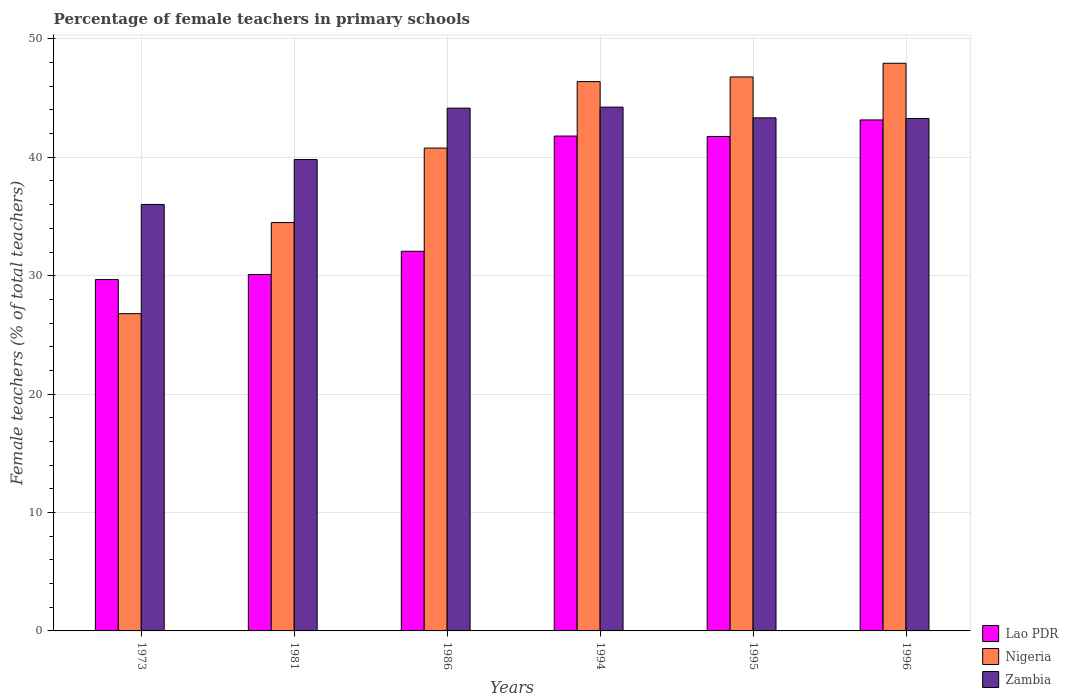How many different coloured bars are there?
Offer a terse response. 3. Are the number of bars on each tick of the X-axis equal?
Make the answer very short. Yes. How many bars are there on the 4th tick from the left?
Your response must be concise. 3. What is the label of the 4th group of bars from the left?
Your response must be concise. 1994. In how many cases, is the number of bars for a given year not equal to the number of legend labels?
Offer a very short reply. 0. What is the percentage of female teachers in Nigeria in 1994?
Your answer should be compact. 46.39. Across all years, what is the maximum percentage of female teachers in Zambia?
Keep it short and to the point. 44.24. Across all years, what is the minimum percentage of female teachers in Nigeria?
Your response must be concise. 26.8. In which year was the percentage of female teachers in Zambia maximum?
Make the answer very short. 1994. In which year was the percentage of female teachers in Lao PDR minimum?
Provide a short and direct response. 1973. What is the total percentage of female teachers in Zambia in the graph?
Make the answer very short. 250.83. What is the difference between the percentage of female teachers in Zambia in 1973 and that in 1995?
Provide a succinct answer. -7.32. What is the difference between the percentage of female teachers in Nigeria in 1996 and the percentage of female teachers in Lao PDR in 1995?
Offer a very short reply. 6.19. What is the average percentage of female teachers in Zambia per year?
Make the answer very short. 41.8. In the year 1995, what is the difference between the percentage of female teachers in Lao PDR and percentage of female teachers in Zambia?
Your answer should be very brief. -1.58. In how many years, is the percentage of female teachers in Lao PDR greater than 14 %?
Give a very brief answer. 6. What is the ratio of the percentage of female teachers in Lao PDR in 1973 to that in 1986?
Make the answer very short. 0.93. Is the difference between the percentage of female teachers in Lao PDR in 1981 and 1995 greater than the difference between the percentage of female teachers in Zambia in 1981 and 1995?
Your answer should be very brief. No. What is the difference between the highest and the second highest percentage of female teachers in Lao PDR?
Offer a terse response. 1.36. What is the difference between the highest and the lowest percentage of female teachers in Lao PDR?
Give a very brief answer. 13.48. Is the sum of the percentage of female teachers in Zambia in 1981 and 1986 greater than the maximum percentage of female teachers in Lao PDR across all years?
Keep it short and to the point. Yes. What does the 3rd bar from the left in 1981 represents?
Your answer should be compact. Zambia. What does the 2nd bar from the right in 1996 represents?
Your answer should be very brief. Nigeria. How many bars are there?
Provide a succinct answer. 18. Does the graph contain any zero values?
Ensure brevity in your answer.  No. Does the graph contain grids?
Your response must be concise. Yes. How many legend labels are there?
Provide a succinct answer. 3. What is the title of the graph?
Make the answer very short. Percentage of female teachers in primary schools. Does "Armenia" appear as one of the legend labels in the graph?
Your response must be concise. No. What is the label or title of the X-axis?
Ensure brevity in your answer.  Years. What is the label or title of the Y-axis?
Keep it short and to the point. Female teachers (% of total teachers). What is the Female teachers (% of total teachers) of Lao PDR in 1973?
Your answer should be compact. 29.67. What is the Female teachers (% of total teachers) in Nigeria in 1973?
Offer a terse response. 26.8. What is the Female teachers (% of total teachers) in Zambia in 1973?
Your answer should be compact. 36.02. What is the Female teachers (% of total teachers) in Lao PDR in 1981?
Your answer should be compact. 30.1. What is the Female teachers (% of total teachers) of Nigeria in 1981?
Your answer should be very brief. 34.49. What is the Female teachers (% of total teachers) in Zambia in 1981?
Your answer should be compact. 39.81. What is the Female teachers (% of total teachers) of Lao PDR in 1986?
Your answer should be very brief. 32.06. What is the Female teachers (% of total teachers) in Nigeria in 1986?
Your answer should be very brief. 40.78. What is the Female teachers (% of total teachers) of Zambia in 1986?
Give a very brief answer. 44.15. What is the Female teachers (% of total teachers) of Lao PDR in 1994?
Offer a terse response. 41.79. What is the Female teachers (% of total teachers) of Nigeria in 1994?
Your answer should be compact. 46.39. What is the Female teachers (% of total teachers) in Zambia in 1994?
Ensure brevity in your answer.  44.24. What is the Female teachers (% of total teachers) of Lao PDR in 1995?
Provide a succinct answer. 41.76. What is the Female teachers (% of total teachers) in Nigeria in 1995?
Ensure brevity in your answer.  46.79. What is the Female teachers (% of total teachers) in Zambia in 1995?
Provide a short and direct response. 43.33. What is the Female teachers (% of total teachers) of Lao PDR in 1996?
Provide a short and direct response. 43.16. What is the Female teachers (% of total teachers) in Nigeria in 1996?
Your answer should be very brief. 47.94. What is the Female teachers (% of total teachers) of Zambia in 1996?
Your answer should be compact. 43.28. Across all years, what is the maximum Female teachers (% of total teachers) in Lao PDR?
Keep it short and to the point. 43.16. Across all years, what is the maximum Female teachers (% of total teachers) in Nigeria?
Keep it short and to the point. 47.94. Across all years, what is the maximum Female teachers (% of total teachers) in Zambia?
Provide a short and direct response. 44.24. Across all years, what is the minimum Female teachers (% of total teachers) in Lao PDR?
Ensure brevity in your answer.  29.67. Across all years, what is the minimum Female teachers (% of total teachers) of Nigeria?
Give a very brief answer. 26.8. Across all years, what is the minimum Female teachers (% of total teachers) in Zambia?
Give a very brief answer. 36.02. What is the total Female teachers (% of total teachers) of Lao PDR in the graph?
Provide a short and direct response. 218.55. What is the total Female teachers (% of total teachers) of Nigeria in the graph?
Give a very brief answer. 243.19. What is the total Female teachers (% of total teachers) of Zambia in the graph?
Provide a short and direct response. 250.83. What is the difference between the Female teachers (% of total teachers) of Lao PDR in 1973 and that in 1981?
Make the answer very short. -0.43. What is the difference between the Female teachers (% of total teachers) of Nigeria in 1973 and that in 1981?
Make the answer very short. -7.69. What is the difference between the Female teachers (% of total teachers) of Zambia in 1973 and that in 1981?
Offer a terse response. -3.79. What is the difference between the Female teachers (% of total teachers) in Lao PDR in 1973 and that in 1986?
Provide a short and direct response. -2.39. What is the difference between the Female teachers (% of total teachers) of Nigeria in 1973 and that in 1986?
Offer a terse response. -13.98. What is the difference between the Female teachers (% of total teachers) of Zambia in 1973 and that in 1986?
Ensure brevity in your answer.  -8.14. What is the difference between the Female teachers (% of total teachers) of Lao PDR in 1973 and that in 1994?
Give a very brief answer. -12.12. What is the difference between the Female teachers (% of total teachers) in Nigeria in 1973 and that in 1994?
Ensure brevity in your answer.  -19.6. What is the difference between the Female teachers (% of total teachers) of Zambia in 1973 and that in 1994?
Your answer should be very brief. -8.22. What is the difference between the Female teachers (% of total teachers) in Lao PDR in 1973 and that in 1995?
Ensure brevity in your answer.  -12.08. What is the difference between the Female teachers (% of total teachers) of Nigeria in 1973 and that in 1995?
Your response must be concise. -19.99. What is the difference between the Female teachers (% of total teachers) in Zambia in 1973 and that in 1995?
Offer a terse response. -7.32. What is the difference between the Female teachers (% of total teachers) in Lao PDR in 1973 and that in 1996?
Keep it short and to the point. -13.48. What is the difference between the Female teachers (% of total teachers) in Nigeria in 1973 and that in 1996?
Provide a succinct answer. -21.15. What is the difference between the Female teachers (% of total teachers) in Zambia in 1973 and that in 1996?
Your answer should be very brief. -7.26. What is the difference between the Female teachers (% of total teachers) in Lao PDR in 1981 and that in 1986?
Provide a succinct answer. -1.96. What is the difference between the Female teachers (% of total teachers) in Nigeria in 1981 and that in 1986?
Offer a very short reply. -6.29. What is the difference between the Female teachers (% of total teachers) in Zambia in 1981 and that in 1986?
Make the answer very short. -4.34. What is the difference between the Female teachers (% of total teachers) in Lao PDR in 1981 and that in 1994?
Ensure brevity in your answer.  -11.69. What is the difference between the Female teachers (% of total teachers) of Nigeria in 1981 and that in 1994?
Give a very brief answer. -11.9. What is the difference between the Female teachers (% of total teachers) in Zambia in 1981 and that in 1994?
Offer a terse response. -4.43. What is the difference between the Female teachers (% of total teachers) in Lao PDR in 1981 and that in 1995?
Your answer should be very brief. -11.66. What is the difference between the Female teachers (% of total teachers) of Nigeria in 1981 and that in 1995?
Keep it short and to the point. -12.3. What is the difference between the Female teachers (% of total teachers) in Zambia in 1981 and that in 1995?
Your answer should be compact. -3.52. What is the difference between the Female teachers (% of total teachers) in Lao PDR in 1981 and that in 1996?
Offer a terse response. -13.06. What is the difference between the Female teachers (% of total teachers) in Nigeria in 1981 and that in 1996?
Ensure brevity in your answer.  -13.45. What is the difference between the Female teachers (% of total teachers) of Zambia in 1981 and that in 1996?
Keep it short and to the point. -3.47. What is the difference between the Female teachers (% of total teachers) in Lao PDR in 1986 and that in 1994?
Your response must be concise. -9.73. What is the difference between the Female teachers (% of total teachers) in Nigeria in 1986 and that in 1994?
Your answer should be very brief. -5.61. What is the difference between the Female teachers (% of total teachers) of Zambia in 1986 and that in 1994?
Make the answer very short. -0.09. What is the difference between the Female teachers (% of total teachers) of Lao PDR in 1986 and that in 1995?
Your response must be concise. -9.69. What is the difference between the Female teachers (% of total teachers) in Nigeria in 1986 and that in 1995?
Keep it short and to the point. -6.01. What is the difference between the Female teachers (% of total teachers) in Zambia in 1986 and that in 1995?
Your response must be concise. 0.82. What is the difference between the Female teachers (% of total teachers) in Lao PDR in 1986 and that in 1996?
Provide a succinct answer. -11.09. What is the difference between the Female teachers (% of total teachers) in Nigeria in 1986 and that in 1996?
Provide a succinct answer. -7.16. What is the difference between the Female teachers (% of total teachers) of Zambia in 1986 and that in 1996?
Provide a short and direct response. 0.87. What is the difference between the Female teachers (% of total teachers) of Lao PDR in 1994 and that in 1995?
Provide a succinct answer. 0.04. What is the difference between the Female teachers (% of total teachers) of Nigeria in 1994 and that in 1995?
Provide a short and direct response. -0.39. What is the difference between the Female teachers (% of total teachers) in Zambia in 1994 and that in 1995?
Ensure brevity in your answer.  0.91. What is the difference between the Female teachers (% of total teachers) in Lao PDR in 1994 and that in 1996?
Your answer should be very brief. -1.36. What is the difference between the Female teachers (% of total teachers) of Nigeria in 1994 and that in 1996?
Make the answer very short. -1.55. What is the difference between the Female teachers (% of total teachers) in Zambia in 1994 and that in 1996?
Offer a very short reply. 0.96. What is the difference between the Female teachers (% of total teachers) in Lao PDR in 1995 and that in 1996?
Offer a terse response. -1.4. What is the difference between the Female teachers (% of total teachers) in Nigeria in 1995 and that in 1996?
Your response must be concise. -1.16. What is the difference between the Female teachers (% of total teachers) in Zambia in 1995 and that in 1996?
Offer a terse response. 0.05. What is the difference between the Female teachers (% of total teachers) in Lao PDR in 1973 and the Female teachers (% of total teachers) in Nigeria in 1981?
Your response must be concise. -4.82. What is the difference between the Female teachers (% of total teachers) of Lao PDR in 1973 and the Female teachers (% of total teachers) of Zambia in 1981?
Provide a succinct answer. -10.14. What is the difference between the Female teachers (% of total teachers) of Nigeria in 1973 and the Female teachers (% of total teachers) of Zambia in 1981?
Make the answer very short. -13.01. What is the difference between the Female teachers (% of total teachers) of Lao PDR in 1973 and the Female teachers (% of total teachers) of Nigeria in 1986?
Your answer should be very brief. -11.11. What is the difference between the Female teachers (% of total teachers) of Lao PDR in 1973 and the Female teachers (% of total teachers) of Zambia in 1986?
Your response must be concise. -14.48. What is the difference between the Female teachers (% of total teachers) in Nigeria in 1973 and the Female teachers (% of total teachers) in Zambia in 1986?
Your answer should be very brief. -17.35. What is the difference between the Female teachers (% of total teachers) in Lao PDR in 1973 and the Female teachers (% of total teachers) in Nigeria in 1994?
Offer a very short reply. -16.72. What is the difference between the Female teachers (% of total teachers) of Lao PDR in 1973 and the Female teachers (% of total teachers) of Zambia in 1994?
Keep it short and to the point. -14.56. What is the difference between the Female teachers (% of total teachers) in Nigeria in 1973 and the Female teachers (% of total teachers) in Zambia in 1994?
Make the answer very short. -17.44. What is the difference between the Female teachers (% of total teachers) of Lao PDR in 1973 and the Female teachers (% of total teachers) of Nigeria in 1995?
Make the answer very short. -17.11. What is the difference between the Female teachers (% of total teachers) in Lao PDR in 1973 and the Female teachers (% of total teachers) in Zambia in 1995?
Give a very brief answer. -13.66. What is the difference between the Female teachers (% of total teachers) in Nigeria in 1973 and the Female teachers (% of total teachers) in Zambia in 1995?
Provide a short and direct response. -16.54. What is the difference between the Female teachers (% of total teachers) of Lao PDR in 1973 and the Female teachers (% of total teachers) of Nigeria in 1996?
Your answer should be compact. -18.27. What is the difference between the Female teachers (% of total teachers) of Lao PDR in 1973 and the Female teachers (% of total teachers) of Zambia in 1996?
Provide a short and direct response. -13.6. What is the difference between the Female teachers (% of total teachers) in Nigeria in 1973 and the Female teachers (% of total teachers) in Zambia in 1996?
Offer a terse response. -16.48. What is the difference between the Female teachers (% of total teachers) in Lao PDR in 1981 and the Female teachers (% of total teachers) in Nigeria in 1986?
Offer a terse response. -10.68. What is the difference between the Female teachers (% of total teachers) in Lao PDR in 1981 and the Female teachers (% of total teachers) in Zambia in 1986?
Make the answer very short. -14.05. What is the difference between the Female teachers (% of total teachers) of Nigeria in 1981 and the Female teachers (% of total teachers) of Zambia in 1986?
Ensure brevity in your answer.  -9.66. What is the difference between the Female teachers (% of total teachers) in Lao PDR in 1981 and the Female teachers (% of total teachers) in Nigeria in 1994?
Make the answer very short. -16.29. What is the difference between the Female teachers (% of total teachers) of Lao PDR in 1981 and the Female teachers (% of total teachers) of Zambia in 1994?
Give a very brief answer. -14.14. What is the difference between the Female teachers (% of total teachers) of Nigeria in 1981 and the Female teachers (% of total teachers) of Zambia in 1994?
Provide a succinct answer. -9.75. What is the difference between the Female teachers (% of total teachers) of Lao PDR in 1981 and the Female teachers (% of total teachers) of Nigeria in 1995?
Make the answer very short. -16.68. What is the difference between the Female teachers (% of total teachers) in Lao PDR in 1981 and the Female teachers (% of total teachers) in Zambia in 1995?
Provide a succinct answer. -13.23. What is the difference between the Female teachers (% of total teachers) in Nigeria in 1981 and the Female teachers (% of total teachers) in Zambia in 1995?
Give a very brief answer. -8.84. What is the difference between the Female teachers (% of total teachers) in Lao PDR in 1981 and the Female teachers (% of total teachers) in Nigeria in 1996?
Provide a succinct answer. -17.84. What is the difference between the Female teachers (% of total teachers) in Lao PDR in 1981 and the Female teachers (% of total teachers) in Zambia in 1996?
Your answer should be very brief. -13.18. What is the difference between the Female teachers (% of total teachers) in Nigeria in 1981 and the Female teachers (% of total teachers) in Zambia in 1996?
Provide a succinct answer. -8.79. What is the difference between the Female teachers (% of total teachers) of Lao PDR in 1986 and the Female teachers (% of total teachers) of Nigeria in 1994?
Give a very brief answer. -14.33. What is the difference between the Female teachers (% of total teachers) in Lao PDR in 1986 and the Female teachers (% of total teachers) in Zambia in 1994?
Make the answer very short. -12.17. What is the difference between the Female teachers (% of total teachers) of Nigeria in 1986 and the Female teachers (% of total teachers) of Zambia in 1994?
Provide a succinct answer. -3.46. What is the difference between the Female teachers (% of total teachers) of Lao PDR in 1986 and the Female teachers (% of total teachers) of Nigeria in 1995?
Provide a short and direct response. -14.72. What is the difference between the Female teachers (% of total teachers) of Lao PDR in 1986 and the Female teachers (% of total teachers) of Zambia in 1995?
Ensure brevity in your answer.  -11.27. What is the difference between the Female teachers (% of total teachers) in Nigeria in 1986 and the Female teachers (% of total teachers) in Zambia in 1995?
Offer a very short reply. -2.55. What is the difference between the Female teachers (% of total teachers) in Lao PDR in 1986 and the Female teachers (% of total teachers) in Nigeria in 1996?
Provide a succinct answer. -15.88. What is the difference between the Female teachers (% of total teachers) of Lao PDR in 1986 and the Female teachers (% of total teachers) of Zambia in 1996?
Your answer should be very brief. -11.21. What is the difference between the Female teachers (% of total teachers) in Nigeria in 1986 and the Female teachers (% of total teachers) in Zambia in 1996?
Offer a terse response. -2.5. What is the difference between the Female teachers (% of total teachers) in Lao PDR in 1994 and the Female teachers (% of total teachers) in Nigeria in 1995?
Your answer should be very brief. -4.99. What is the difference between the Female teachers (% of total teachers) of Lao PDR in 1994 and the Female teachers (% of total teachers) of Zambia in 1995?
Ensure brevity in your answer.  -1.54. What is the difference between the Female teachers (% of total teachers) in Nigeria in 1994 and the Female teachers (% of total teachers) in Zambia in 1995?
Ensure brevity in your answer.  3.06. What is the difference between the Female teachers (% of total teachers) in Lao PDR in 1994 and the Female teachers (% of total teachers) in Nigeria in 1996?
Provide a short and direct response. -6.15. What is the difference between the Female teachers (% of total teachers) of Lao PDR in 1994 and the Female teachers (% of total teachers) of Zambia in 1996?
Give a very brief answer. -1.48. What is the difference between the Female teachers (% of total teachers) in Nigeria in 1994 and the Female teachers (% of total teachers) in Zambia in 1996?
Provide a succinct answer. 3.12. What is the difference between the Female teachers (% of total teachers) of Lao PDR in 1995 and the Female teachers (% of total teachers) of Nigeria in 1996?
Your response must be concise. -6.19. What is the difference between the Female teachers (% of total teachers) in Lao PDR in 1995 and the Female teachers (% of total teachers) in Zambia in 1996?
Give a very brief answer. -1.52. What is the difference between the Female teachers (% of total teachers) in Nigeria in 1995 and the Female teachers (% of total teachers) in Zambia in 1996?
Your answer should be very brief. 3.51. What is the average Female teachers (% of total teachers) in Lao PDR per year?
Provide a succinct answer. 36.42. What is the average Female teachers (% of total teachers) in Nigeria per year?
Offer a very short reply. 40.53. What is the average Female teachers (% of total teachers) of Zambia per year?
Offer a very short reply. 41.8. In the year 1973, what is the difference between the Female teachers (% of total teachers) of Lao PDR and Female teachers (% of total teachers) of Nigeria?
Offer a very short reply. 2.88. In the year 1973, what is the difference between the Female teachers (% of total teachers) in Lao PDR and Female teachers (% of total teachers) in Zambia?
Provide a short and direct response. -6.34. In the year 1973, what is the difference between the Female teachers (% of total teachers) of Nigeria and Female teachers (% of total teachers) of Zambia?
Give a very brief answer. -9.22. In the year 1981, what is the difference between the Female teachers (% of total teachers) in Lao PDR and Female teachers (% of total teachers) in Nigeria?
Offer a very short reply. -4.39. In the year 1981, what is the difference between the Female teachers (% of total teachers) of Lao PDR and Female teachers (% of total teachers) of Zambia?
Your answer should be very brief. -9.71. In the year 1981, what is the difference between the Female teachers (% of total teachers) of Nigeria and Female teachers (% of total teachers) of Zambia?
Keep it short and to the point. -5.32. In the year 1986, what is the difference between the Female teachers (% of total teachers) of Lao PDR and Female teachers (% of total teachers) of Nigeria?
Offer a very short reply. -8.71. In the year 1986, what is the difference between the Female teachers (% of total teachers) in Lao PDR and Female teachers (% of total teachers) in Zambia?
Your answer should be very brief. -12.09. In the year 1986, what is the difference between the Female teachers (% of total teachers) in Nigeria and Female teachers (% of total teachers) in Zambia?
Your answer should be compact. -3.37. In the year 1994, what is the difference between the Female teachers (% of total teachers) in Lao PDR and Female teachers (% of total teachers) in Nigeria?
Your answer should be compact. -4.6. In the year 1994, what is the difference between the Female teachers (% of total teachers) of Lao PDR and Female teachers (% of total teachers) of Zambia?
Your answer should be compact. -2.44. In the year 1994, what is the difference between the Female teachers (% of total teachers) of Nigeria and Female teachers (% of total teachers) of Zambia?
Make the answer very short. 2.15. In the year 1995, what is the difference between the Female teachers (% of total teachers) in Lao PDR and Female teachers (% of total teachers) in Nigeria?
Provide a succinct answer. -5.03. In the year 1995, what is the difference between the Female teachers (% of total teachers) of Lao PDR and Female teachers (% of total teachers) of Zambia?
Your answer should be compact. -1.58. In the year 1995, what is the difference between the Female teachers (% of total teachers) in Nigeria and Female teachers (% of total teachers) in Zambia?
Offer a very short reply. 3.45. In the year 1996, what is the difference between the Female teachers (% of total teachers) of Lao PDR and Female teachers (% of total teachers) of Nigeria?
Ensure brevity in your answer.  -4.79. In the year 1996, what is the difference between the Female teachers (% of total teachers) of Lao PDR and Female teachers (% of total teachers) of Zambia?
Make the answer very short. -0.12. In the year 1996, what is the difference between the Female teachers (% of total teachers) in Nigeria and Female teachers (% of total teachers) in Zambia?
Make the answer very short. 4.67. What is the ratio of the Female teachers (% of total teachers) of Lao PDR in 1973 to that in 1981?
Ensure brevity in your answer.  0.99. What is the ratio of the Female teachers (% of total teachers) of Nigeria in 1973 to that in 1981?
Provide a succinct answer. 0.78. What is the ratio of the Female teachers (% of total teachers) of Zambia in 1973 to that in 1981?
Ensure brevity in your answer.  0.9. What is the ratio of the Female teachers (% of total teachers) of Lao PDR in 1973 to that in 1986?
Your response must be concise. 0.93. What is the ratio of the Female teachers (% of total teachers) of Nigeria in 1973 to that in 1986?
Provide a short and direct response. 0.66. What is the ratio of the Female teachers (% of total teachers) of Zambia in 1973 to that in 1986?
Offer a very short reply. 0.82. What is the ratio of the Female teachers (% of total teachers) in Lao PDR in 1973 to that in 1994?
Provide a short and direct response. 0.71. What is the ratio of the Female teachers (% of total teachers) of Nigeria in 1973 to that in 1994?
Give a very brief answer. 0.58. What is the ratio of the Female teachers (% of total teachers) of Zambia in 1973 to that in 1994?
Give a very brief answer. 0.81. What is the ratio of the Female teachers (% of total teachers) of Lao PDR in 1973 to that in 1995?
Make the answer very short. 0.71. What is the ratio of the Female teachers (% of total teachers) in Nigeria in 1973 to that in 1995?
Offer a terse response. 0.57. What is the ratio of the Female teachers (% of total teachers) of Zambia in 1973 to that in 1995?
Provide a short and direct response. 0.83. What is the ratio of the Female teachers (% of total teachers) in Lao PDR in 1973 to that in 1996?
Provide a succinct answer. 0.69. What is the ratio of the Female teachers (% of total teachers) of Nigeria in 1973 to that in 1996?
Provide a succinct answer. 0.56. What is the ratio of the Female teachers (% of total teachers) in Zambia in 1973 to that in 1996?
Ensure brevity in your answer.  0.83. What is the ratio of the Female teachers (% of total teachers) in Lao PDR in 1981 to that in 1986?
Provide a succinct answer. 0.94. What is the ratio of the Female teachers (% of total teachers) of Nigeria in 1981 to that in 1986?
Your response must be concise. 0.85. What is the ratio of the Female teachers (% of total teachers) in Zambia in 1981 to that in 1986?
Your response must be concise. 0.9. What is the ratio of the Female teachers (% of total teachers) of Lao PDR in 1981 to that in 1994?
Your response must be concise. 0.72. What is the ratio of the Female teachers (% of total teachers) of Nigeria in 1981 to that in 1994?
Your response must be concise. 0.74. What is the ratio of the Female teachers (% of total teachers) of Zambia in 1981 to that in 1994?
Offer a very short reply. 0.9. What is the ratio of the Female teachers (% of total teachers) in Lao PDR in 1981 to that in 1995?
Make the answer very short. 0.72. What is the ratio of the Female teachers (% of total teachers) in Nigeria in 1981 to that in 1995?
Your response must be concise. 0.74. What is the ratio of the Female teachers (% of total teachers) in Zambia in 1981 to that in 1995?
Your answer should be very brief. 0.92. What is the ratio of the Female teachers (% of total teachers) in Lao PDR in 1981 to that in 1996?
Give a very brief answer. 0.7. What is the ratio of the Female teachers (% of total teachers) in Nigeria in 1981 to that in 1996?
Offer a terse response. 0.72. What is the ratio of the Female teachers (% of total teachers) of Zambia in 1981 to that in 1996?
Keep it short and to the point. 0.92. What is the ratio of the Female teachers (% of total teachers) of Lao PDR in 1986 to that in 1994?
Offer a terse response. 0.77. What is the ratio of the Female teachers (% of total teachers) of Nigeria in 1986 to that in 1994?
Make the answer very short. 0.88. What is the ratio of the Female teachers (% of total teachers) in Lao PDR in 1986 to that in 1995?
Offer a very short reply. 0.77. What is the ratio of the Female teachers (% of total teachers) of Nigeria in 1986 to that in 1995?
Your response must be concise. 0.87. What is the ratio of the Female teachers (% of total teachers) in Zambia in 1986 to that in 1995?
Your answer should be compact. 1.02. What is the ratio of the Female teachers (% of total teachers) of Lao PDR in 1986 to that in 1996?
Offer a very short reply. 0.74. What is the ratio of the Female teachers (% of total teachers) of Nigeria in 1986 to that in 1996?
Ensure brevity in your answer.  0.85. What is the ratio of the Female teachers (% of total teachers) of Zambia in 1986 to that in 1996?
Make the answer very short. 1.02. What is the ratio of the Female teachers (% of total teachers) of Nigeria in 1994 to that in 1995?
Make the answer very short. 0.99. What is the ratio of the Female teachers (% of total teachers) of Zambia in 1994 to that in 1995?
Make the answer very short. 1.02. What is the ratio of the Female teachers (% of total teachers) in Lao PDR in 1994 to that in 1996?
Ensure brevity in your answer.  0.97. What is the ratio of the Female teachers (% of total teachers) of Nigeria in 1994 to that in 1996?
Ensure brevity in your answer.  0.97. What is the ratio of the Female teachers (% of total teachers) of Zambia in 1994 to that in 1996?
Ensure brevity in your answer.  1.02. What is the ratio of the Female teachers (% of total teachers) of Lao PDR in 1995 to that in 1996?
Offer a very short reply. 0.97. What is the ratio of the Female teachers (% of total teachers) of Nigeria in 1995 to that in 1996?
Your answer should be very brief. 0.98. What is the difference between the highest and the second highest Female teachers (% of total teachers) of Lao PDR?
Offer a terse response. 1.36. What is the difference between the highest and the second highest Female teachers (% of total teachers) of Nigeria?
Ensure brevity in your answer.  1.16. What is the difference between the highest and the second highest Female teachers (% of total teachers) of Zambia?
Provide a short and direct response. 0.09. What is the difference between the highest and the lowest Female teachers (% of total teachers) of Lao PDR?
Keep it short and to the point. 13.48. What is the difference between the highest and the lowest Female teachers (% of total teachers) in Nigeria?
Keep it short and to the point. 21.15. What is the difference between the highest and the lowest Female teachers (% of total teachers) in Zambia?
Your answer should be compact. 8.22. 